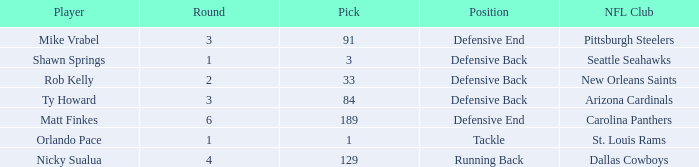What round has a pick less than 189, with arizona cardinals as the NFL club? 3.0. 